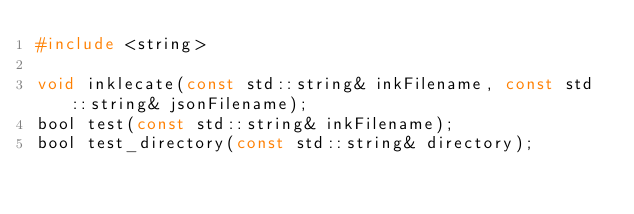<code> <loc_0><loc_0><loc_500><loc_500><_C_>#include <string>

void inklecate(const std::string& inkFilename, const std::string& jsonFilename);
bool test(const std::string& inkFilename);
bool test_directory(const std::string& directory);</code> 